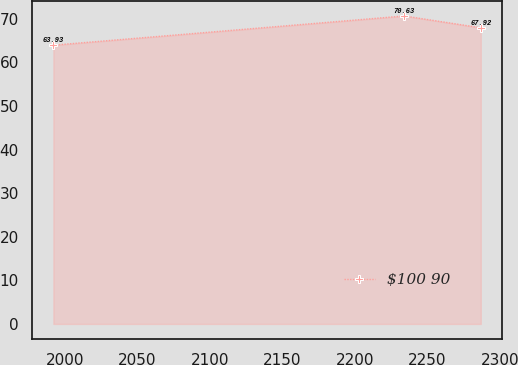<chart> <loc_0><loc_0><loc_500><loc_500><line_chart><ecel><fcel>$100 90<nl><fcel>1991.94<fcel>63.93<nl><fcel>2233.94<fcel>70.63<nl><fcel>2286.76<fcel>67.92<nl></chart> 